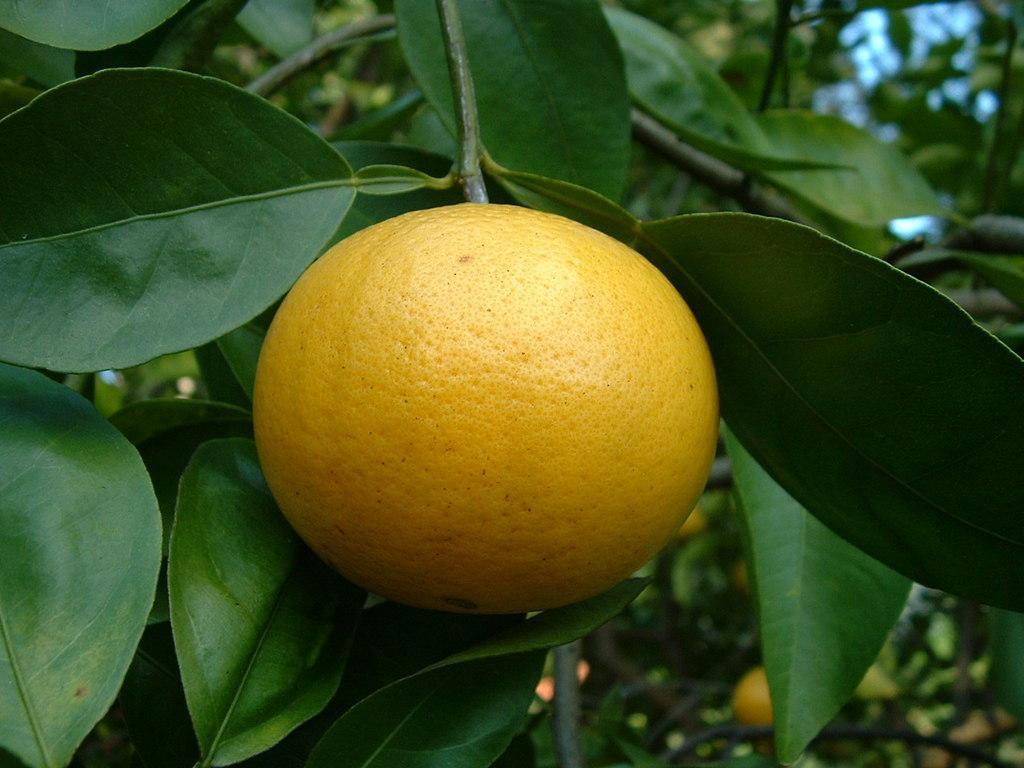How would you summarize this image in a sentence or two? This picture shows few oranges to the trees. 